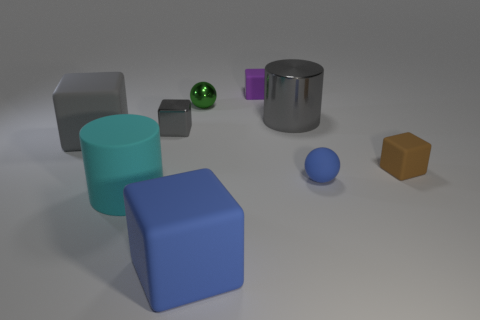Subtract all purple blocks. How many blocks are left? 4 Subtract all green cylinders. Subtract all red spheres. How many cylinders are left? 2 Add 1 big cyan rubber spheres. How many objects exist? 10 Subtract all cylinders. How many objects are left? 7 Subtract all purple rubber spheres. Subtract all small gray metallic cubes. How many objects are left? 8 Add 1 small green metal spheres. How many small green metal spheres are left? 2 Add 4 small yellow shiny objects. How many small yellow shiny objects exist? 4 Subtract 0 red spheres. How many objects are left? 9 